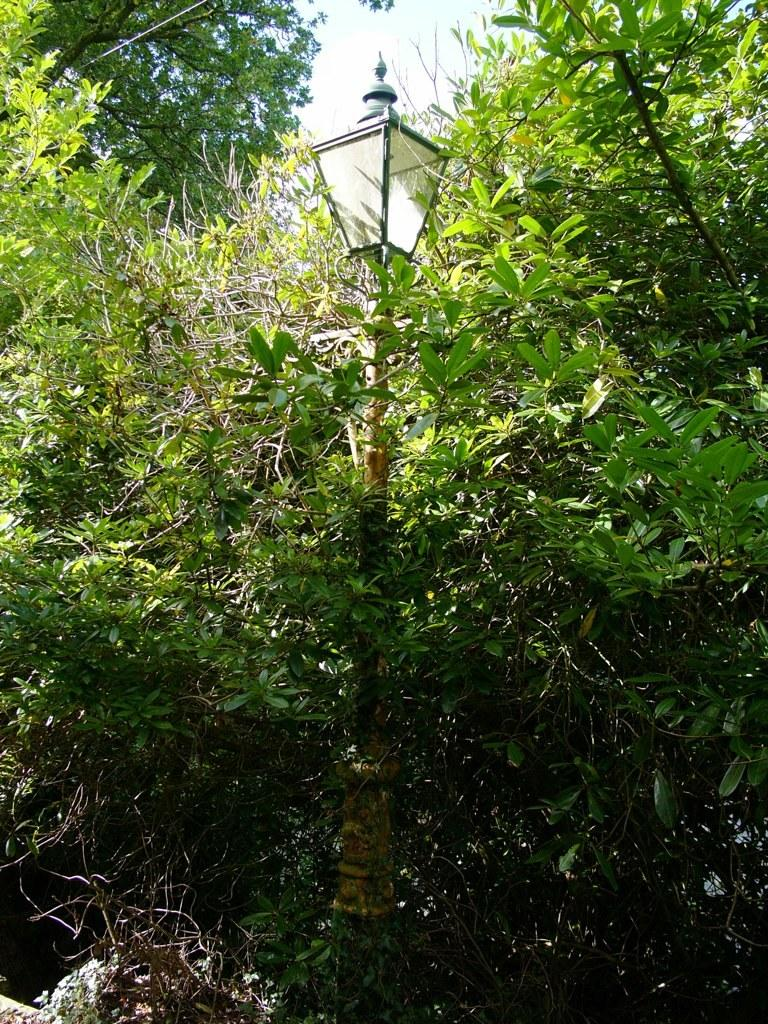What is on the pole in the image? There is a light on a pole in the image. What type of vegetation can be seen in the image? There are plants and trees in the image. What can be seen in the background of the image? The sky is visible in the background of the image. What type of game is being played in the image? There is no game being played in the image; it features a light on a pole, plants, trees, and the sky. What is the income of the trees in the image? Trees do not have an income, as they are living organisms and not capable of earning money. 